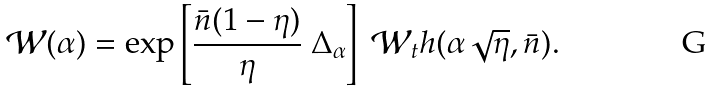<formula> <loc_0><loc_0><loc_500><loc_500>\mathcal { W } ( \alpha ) = \exp \left [ \frac { \bar { n } ( 1 - \eta ) } { \eta } \ \Delta _ { \alpha } \right ] \ \mathcal { W } _ { t } h ( \alpha \sqrt { \eta } , \bar { n } ) .</formula> 